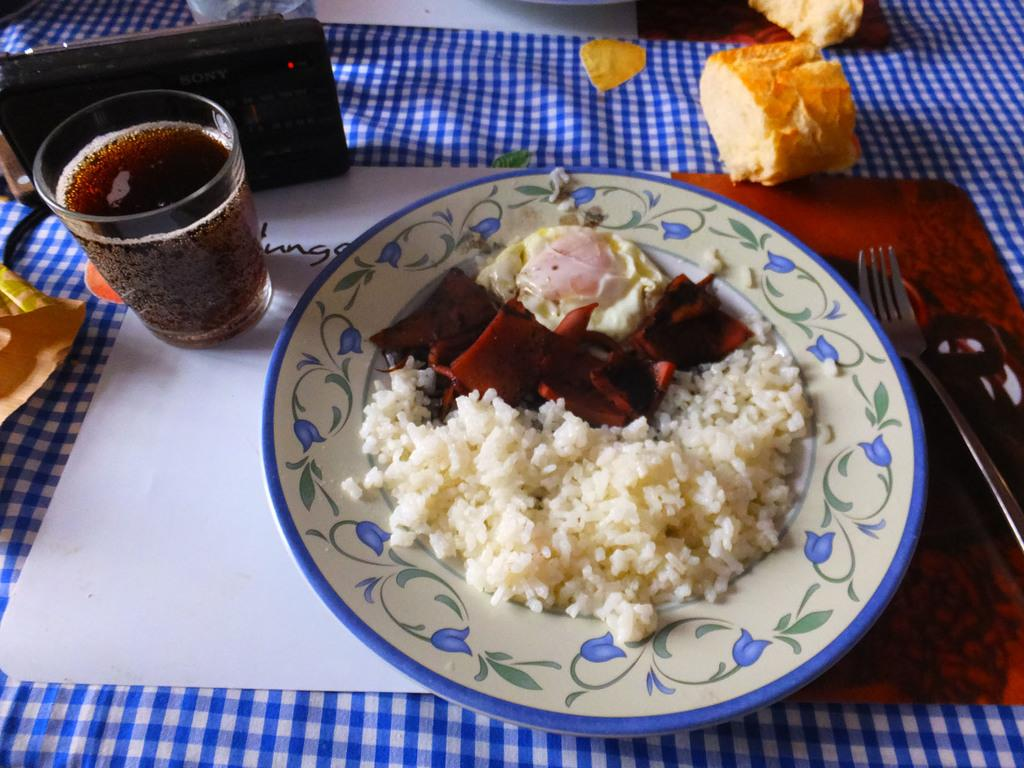What is the main object in the center of the image? There is a table in the center of the image. What is on the table? There is a plate containing food, a glass, a camera, bread, and a fork on the table. What is the library's fear of the range in the image? There is no library or range present in the image, so this question cannot be answered. 